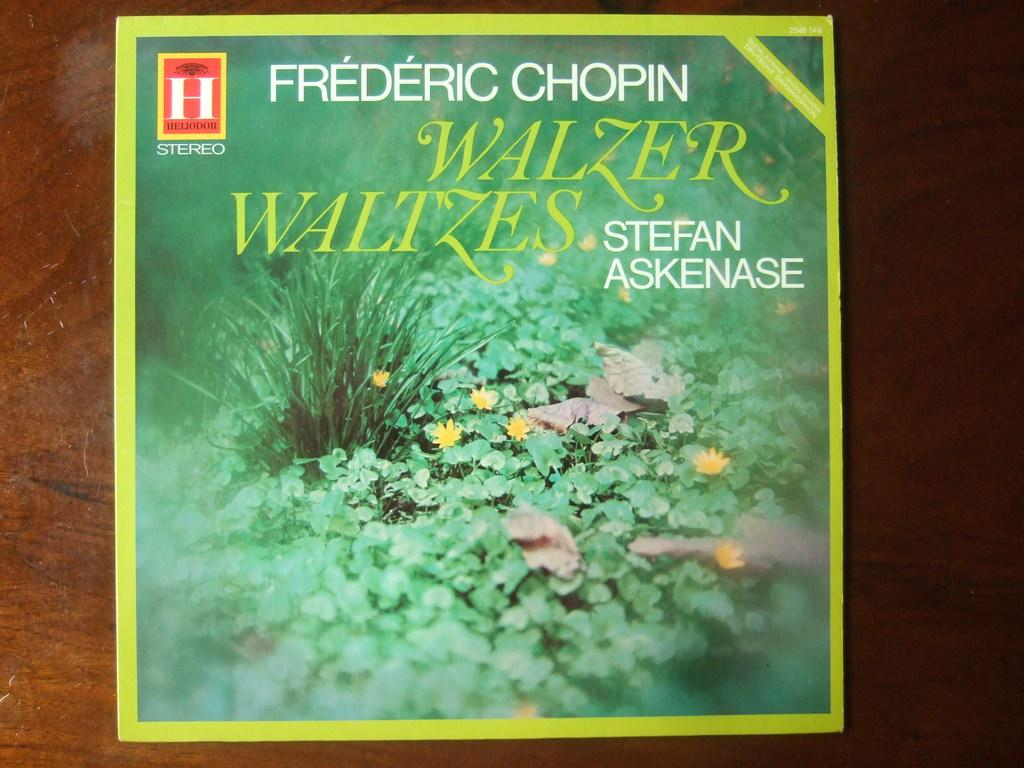Provide a one-sentence caption for the provided image. A record album showing a field of green grass and yellow flowers containing music composed by Chopin. 